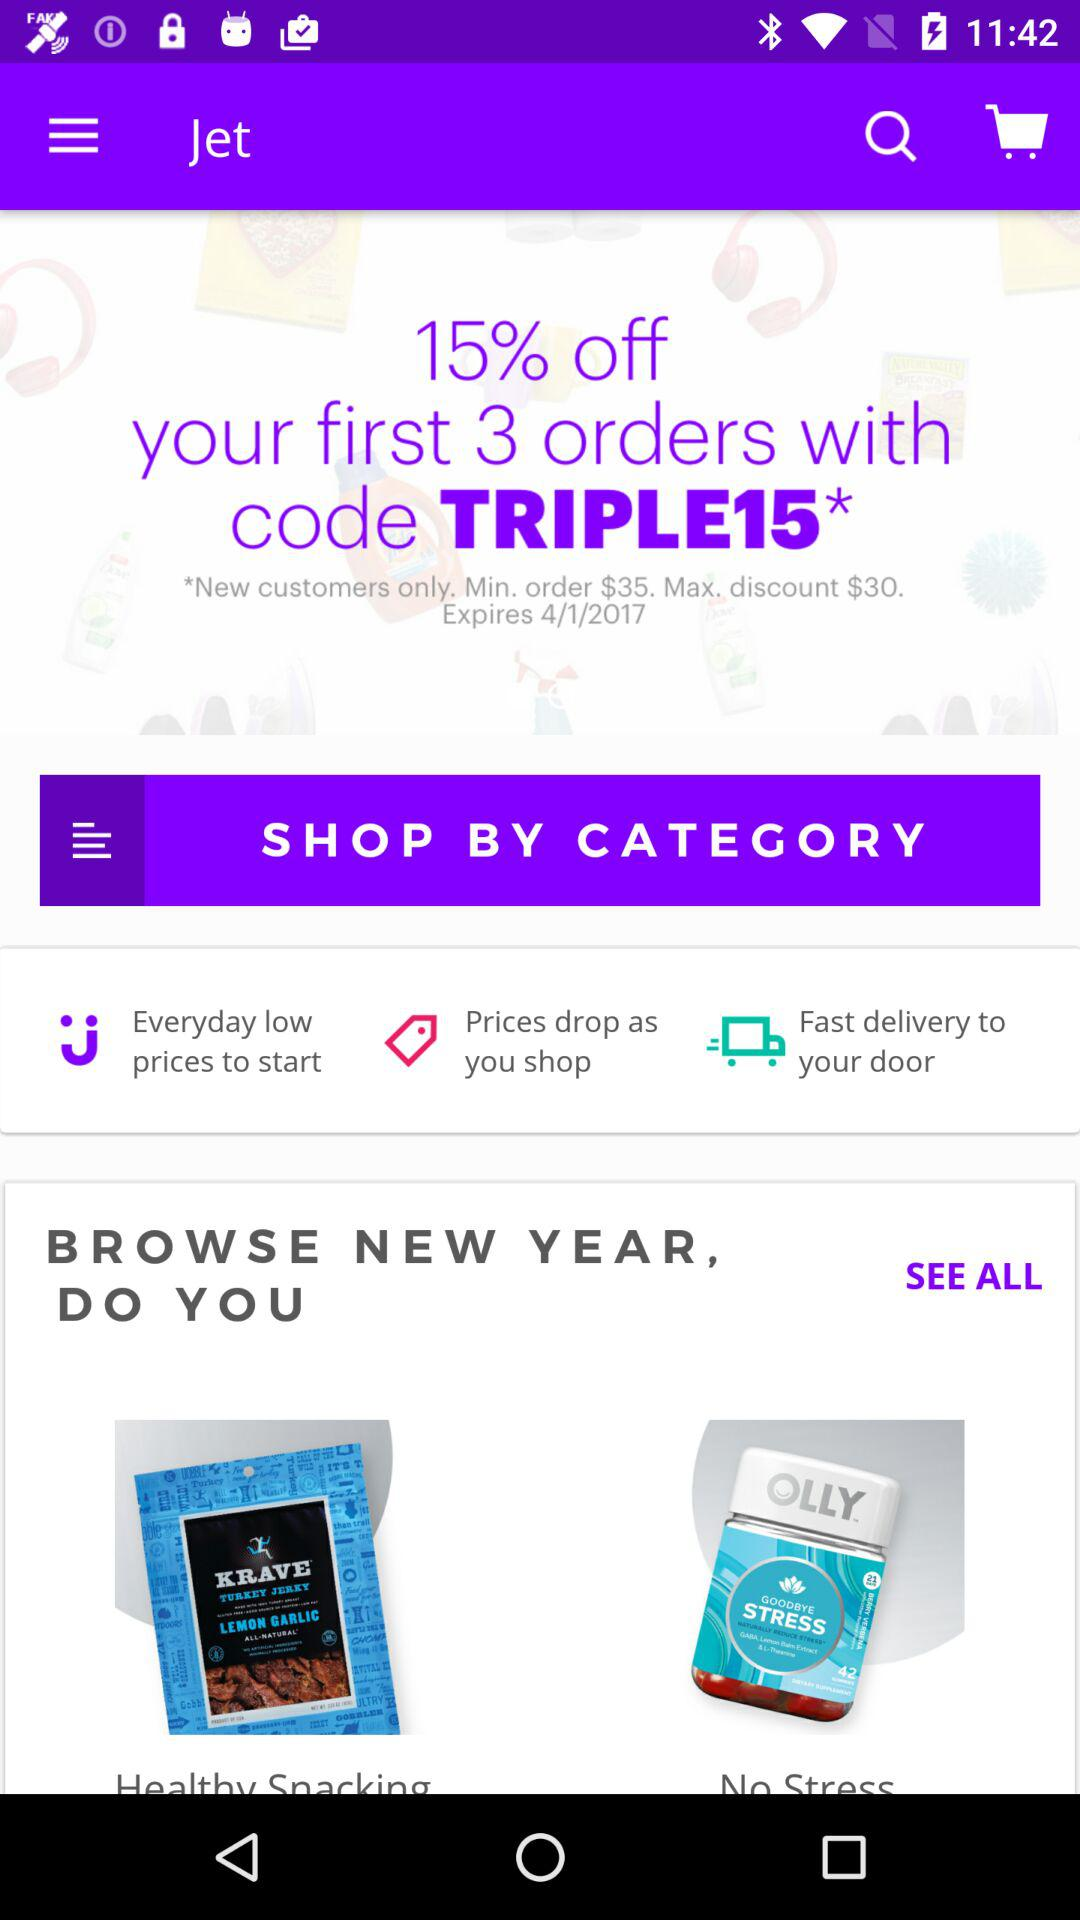What is the maximum discount on the product? The maximum discount on the product is $30. 